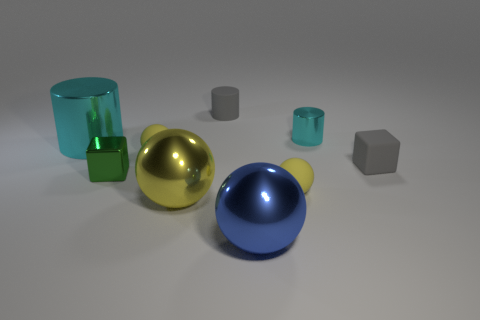How many big things are either cyan things or yellow things?
Provide a succinct answer. 2. What is the material of the ball that is both right of the big yellow sphere and behind the big blue shiny object?
Ensure brevity in your answer.  Rubber. There is a small object in front of the green thing; is it the same shape as the cyan metal thing right of the large blue metal ball?
Make the answer very short. No. What is the shape of the metal object that is the same color as the tiny metallic cylinder?
Your answer should be compact. Cylinder. What number of things are either blue spheres right of the green shiny thing or cubes?
Your response must be concise. 3. Do the green thing and the gray cylinder have the same size?
Your response must be concise. Yes. There is a sphere that is behind the tiny gray block; what color is it?
Your answer should be very brief. Yellow. There is a green block that is the same material as the tiny cyan thing; what size is it?
Your answer should be compact. Small. There is a gray cylinder; does it have the same size as the cyan shiny thing in front of the small metallic cylinder?
Offer a very short reply. No. There is a cyan thing that is on the left side of the small green thing; what is its material?
Provide a succinct answer. Metal. 